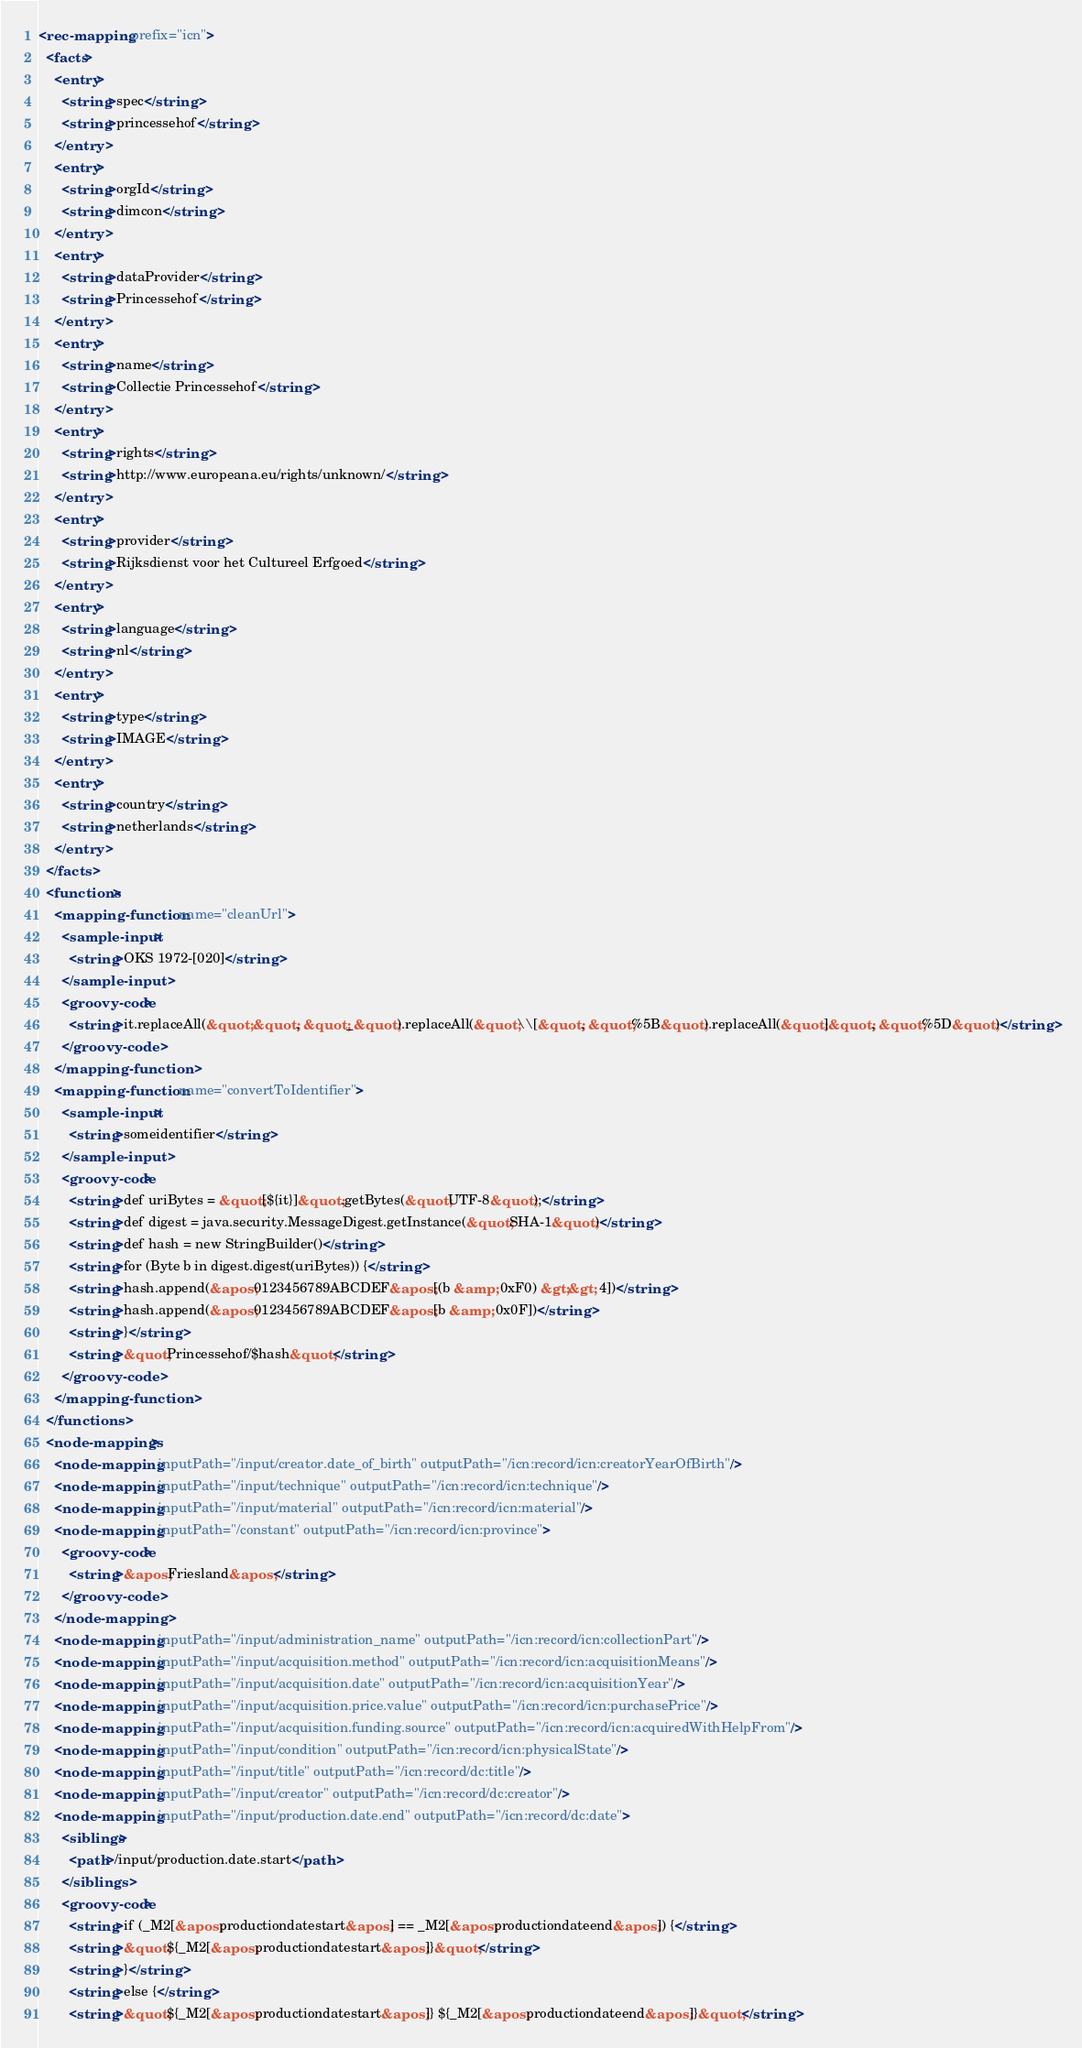Convert code to text. <code><loc_0><loc_0><loc_500><loc_500><_XML_><rec-mapping prefix="icn">
  <facts>
    <entry>
      <string>spec</string>
      <string>princessehof</string>
    </entry>
    <entry>
      <string>orgId</string>
      <string>dimcon</string>
    </entry>
    <entry>
      <string>dataProvider</string>
      <string>Princessehof</string>
    </entry>
    <entry>
      <string>name</string>
      <string>Collectie Princessehof</string>
    </entry>
    <entry>
      <string>rights</string>
      <string>http://www.europeana.eu/rights/unknown/</string>
    </entry>
    <entry>
      <string>provider</string>
      <string>Rijksdienst voor het Cultureel Erfgoed</string>
    </entry>
    <entry>
      <string>language</string>
      <string>nl</string>
    </entry>
    <entry>
      <string>type</string>
      <string>IMAGE</string>
    </entry>
    <entry>
      <string>country</string>
      <string>netherlands</string>
    </entry>
  </facts>
  <functions>
    <mapping-function name="cleanUrl">
      <sample-input>
        <string>OKS 1972-[020]</string>
      </sample-input>
      <groovy-code>
        <string>it.replaceAll(&quot; &quot;, &quot;_&quot;).replaceAll(&quot;\\[&quot;, &quot;%5B&quot;).replaceAll(&quot;]&quot;, &quot;%5D&quot;)</string>
      </groovy-code>
    </mapping-function>
    <mapping-function name="convertToIdentifier">
      <sample-input>
        <string>someidentifier</string>
      </sample-input>
      <groovy-code>
        <string>def uriBytes = &quot;[${it}]&quot;.getBytes(&quot;UTF-8&quot;);</string>
        <string>def digest = java.security.MessageDigest.getInstance(&quot;SHA-1&quot;)</string>
        <string>def hash = new StringBuilder()</string>
        <string>for (Byte b in digest.digest(uriBytes)) {</string>
        <string>hash.append(&apos;0123456789ABCDEF&apos;[(b &amp; 0xF0) &gt;&gt; 4])</string>
        <string>hash.append(&apos;0123456789ABCDEF&apos;[b &amp; 0x0F])</string>
        <string>}</string>
        <string>&quot;Princessehof/$hash&quot;</string>
      </groovy-code>
    </mapping-function>
  </functions>
  <node-mappings>
    <node-mapping inputPath="/input/creator.date_of_birth" outputPath="/icn:record/icn:creatorYearOfBirth"/>
    <node-mapping inputPath="/input/technique" outputPath="/icn:record/icn:technique"/>
    <node-mapping inputPath="/input/material" outputPath="/icn:record/icn:material"/>
    <node-mapping inputPath="/constant" outputPath="/icn:record/icn:province">
      <groovy-code>
        <string>&apos;Friesland&apos;</string>
      </groovy-code>
    </node-mapping>
    <node-mapping inputPath="/input/administration_name" outputPath="/icn:record/icn:collectionPart"/>
    <node-mapping inputPath="/input/acquisition.method" outputPath="/icn:record/icn:acquisitionMeans"/>
    <node-mapping inputPath="/input/acquisition.date" outputPath="/icn:record/icn:acquisitionYear"/>
    <node-mapping inputPath="/input/acquisition.price.value" outputPath="/icn:record/icn:purchasePrice"/>
    <node-mapping inputPath="/input/acquisition.funding.source" outputPath="/icn:record/icn:acquiredWithHelpFrom"/>
    <node-mapping inputPath="/input/condition" outputPath="/icn:record/icn:physicalState"/>
    <node-mapping inputPath="/input/title" outputPath="/icn:record/dc:title"/>
    <node-mapping inputPath="/input/creator" outputPath="/icn:record/dc:creator"/>
    <node-mapping inputPath="/input/production.date.end" outputPath="/icn:record/dc:date">
      <siblings>
        <path>/input/production.date.start</path>
      </siblings>
      <groovy-code>
        <string>if (_M2[&apos;productiondatestart&apos;] == _M2[&apos;productiondateend&apos;]) {</string>
        <string>&quot;${_M2[&apos;productiondatestart&apos;]}&quot;</string>
        <string>}</string>
        <string>else {</string>
        <string>&quot;${_M2[&apos;productiondatestart&apos;]} ${_M2[&apos;productiondateend&apos;]}&quot;</string></code> 